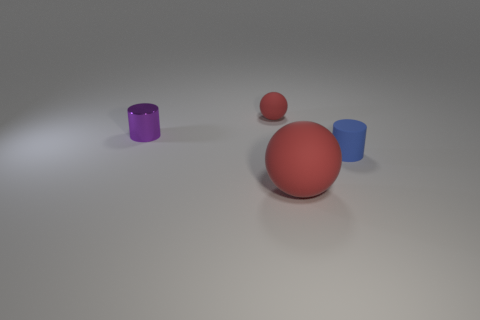How do the textures of the objects differ? The objects in the image have distinct textures: the spheres have a shiny, reflective surface, while the cylindrical objects showcase a matte finish that diffuses light, giving them a non-reflective appearance. 